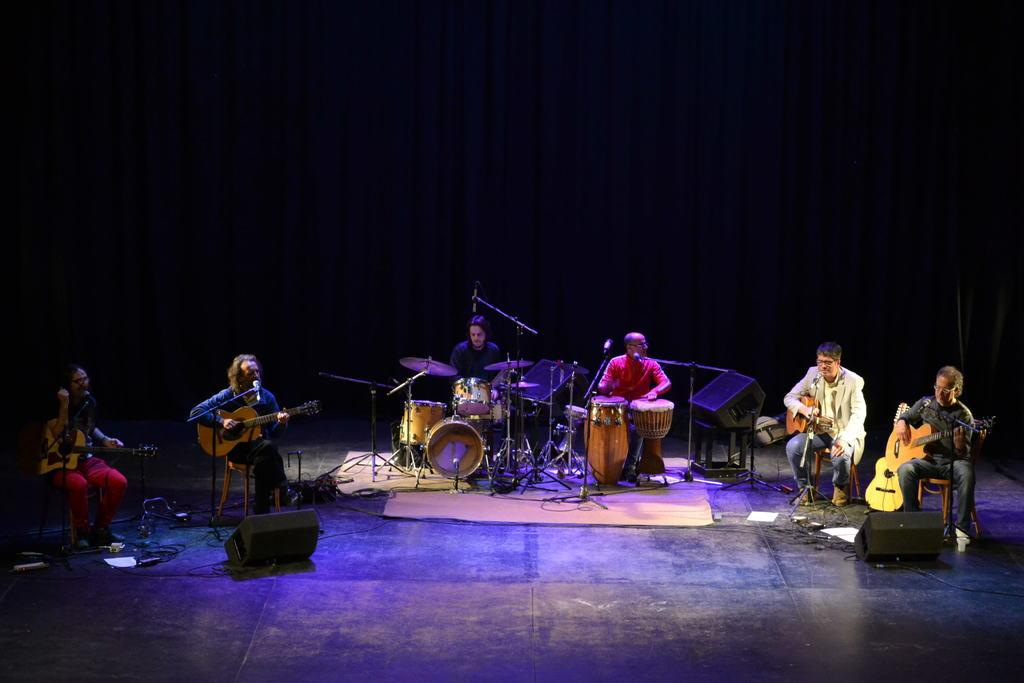What type of group is present in the image? There is a music band in the image. What are the band members doing? The band members are playing different musical instruments. How are the band members positioned in the image? The band members are sitting on stools on the floor. What can be seen in the background of the image? There is a curtain in the background of the image. Can you see the toes of the band members in the image? There is no indication of the band members' toes in the image, as they are sitting on stools and playing musical instruments. 